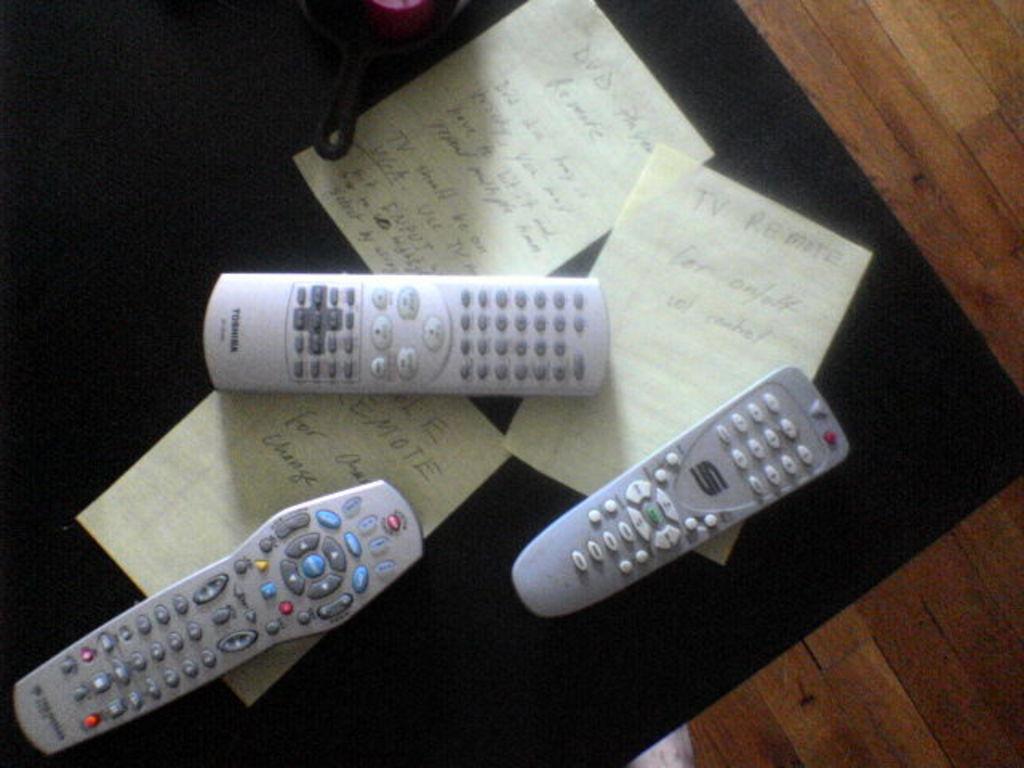What is the remote maker in the top center?
Your answer should be compact. Toshiba. 